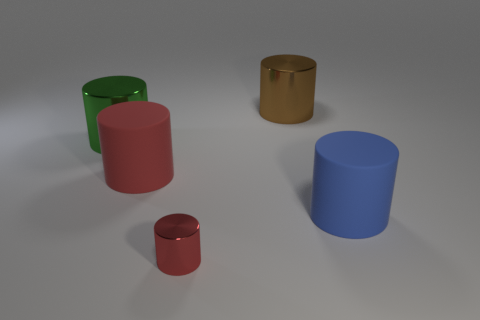How many objects are there in the image, and can you describe their colors? The image features five objects. Starting from the left, there's a large green cylinder, a medium-sized pink rubber cylinder, a small red metal cylinder, a large blue cylinder, and finally, a medium-sized shiny, golden cylinder. 